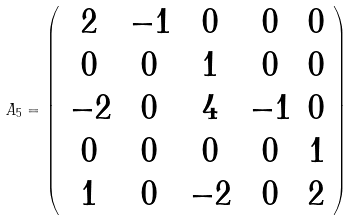Convert formula to latex. <formula><loc_0><loc_0><loc_500><loc_500>\ A _ { 5 } = \left ( \begin{array} { c c c c c } 2 & - 1 & 0 & 0 & 0 \\ 0 & 0 & 1 & 0 & 0 \\ - 2 & 0 & 4 & - 1 & 0 \\ 0 & 0 & 0 & 0 & 1 \\ 1 & 0 & - 2 & 0 & 2 \end{array} \right )</formula> 